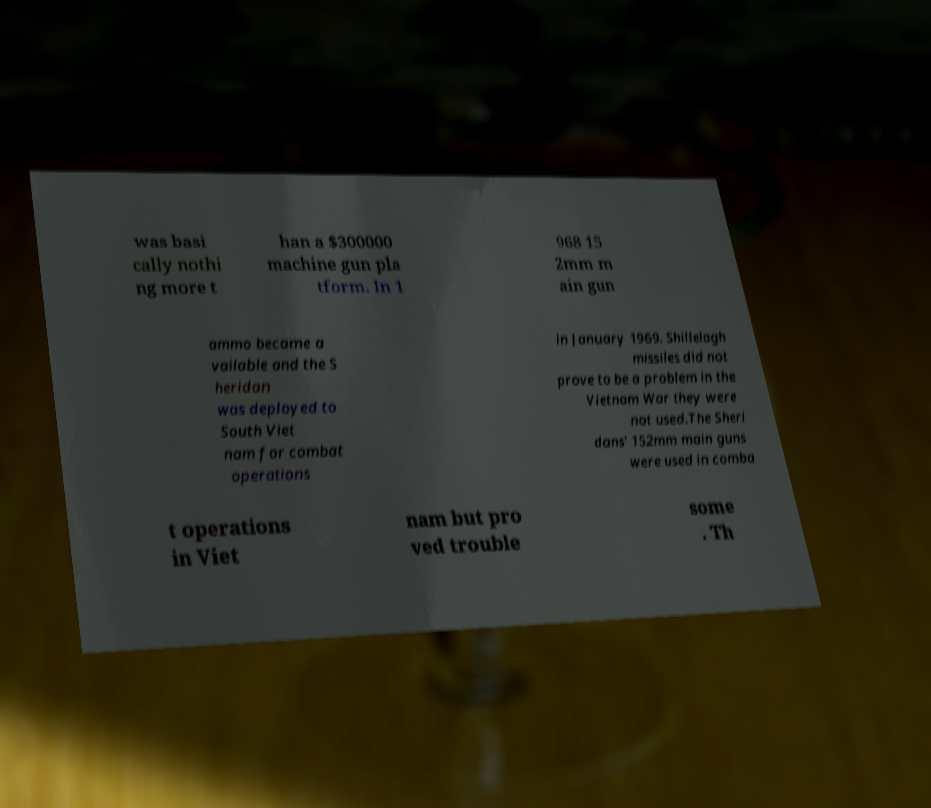Could you extract and type out the text from this image? was basi cally nothi ng more t han a $300000 machine gun pla tform. In 1 968 15 2mm m ain gun ammo became a vailable and the S heridan was deployed to South Viet nam for combat operations in January 1969. Shillelagh missiles did not prove to be a problem in the Vietnam War they were not used.The Sheri dans' 152mm main guns were used in comba t operations in Viet nam but pro ved trouble some . Th 